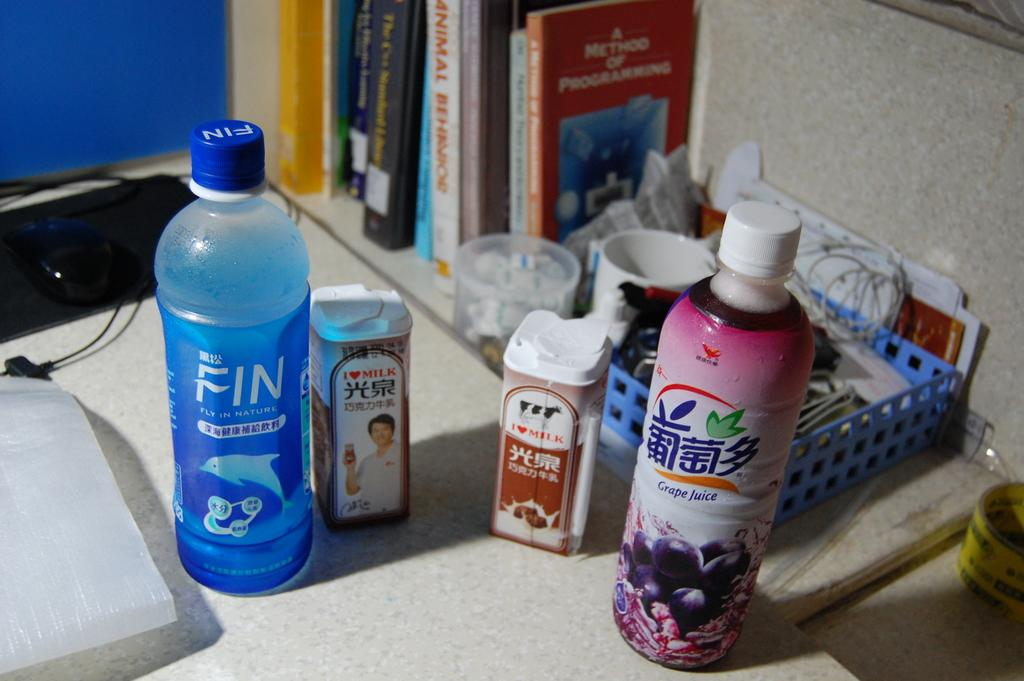Provide a one-sentence caption for the provided image. A Fly In Nature bottle sits on a counter next to other products. 